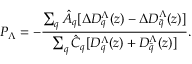<formula> <loc_0><loc_0><loc_500><loc_500>P _ { \Lambda } = - \frac { \sum _ { q } \hat { A } _ { q } [ \Delta D _ { q } ^ { \Lambda } ( z ) - \Delta D _ { \bar { q } } ^ { \Lambda } ( z ) ] } { \sum _ { q } \hat { C } _ { q } [ D _ { q } ^ { \Lambda } ( z ) + D _ { \bar { q } } ^ { \Lambda } ( z ) ] } .</formula> 